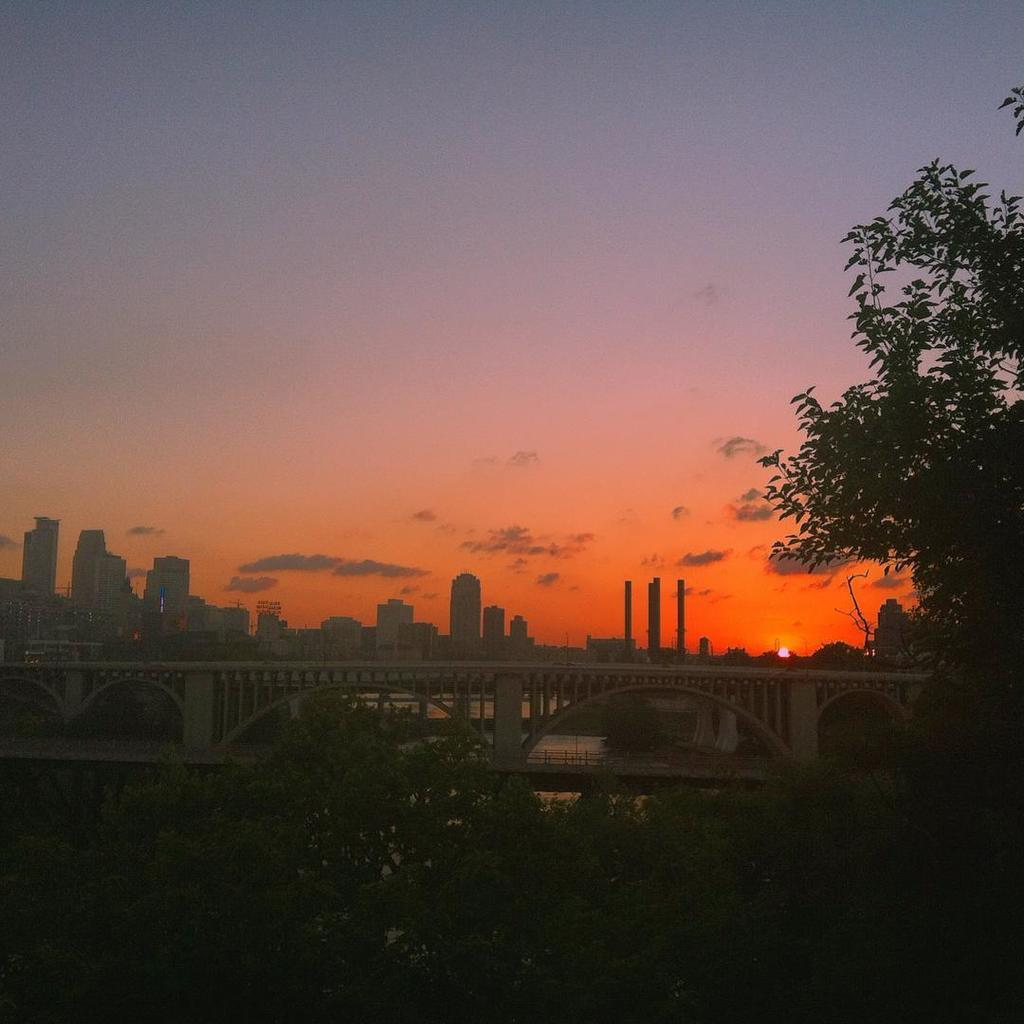What type of structure can be seen in the image? There is a bridge in the image. What natural element is visible in the image? There is water visible in the image. What type of man-made structures can be seen in the image? There are buildings in the image. What type of vegetation is present in the image? There are trees in the image. What is visible in the background of the image? The sky is visible in the background of the image. What type of can is visible in the image? There is no can present in the image. What type of motion can be observed in the image? The image is a still photograph, so there is no motion visible. What is the condition of the throat of the person in the image? There is no person present in the image, so we cannot determine the condition of their throat. 